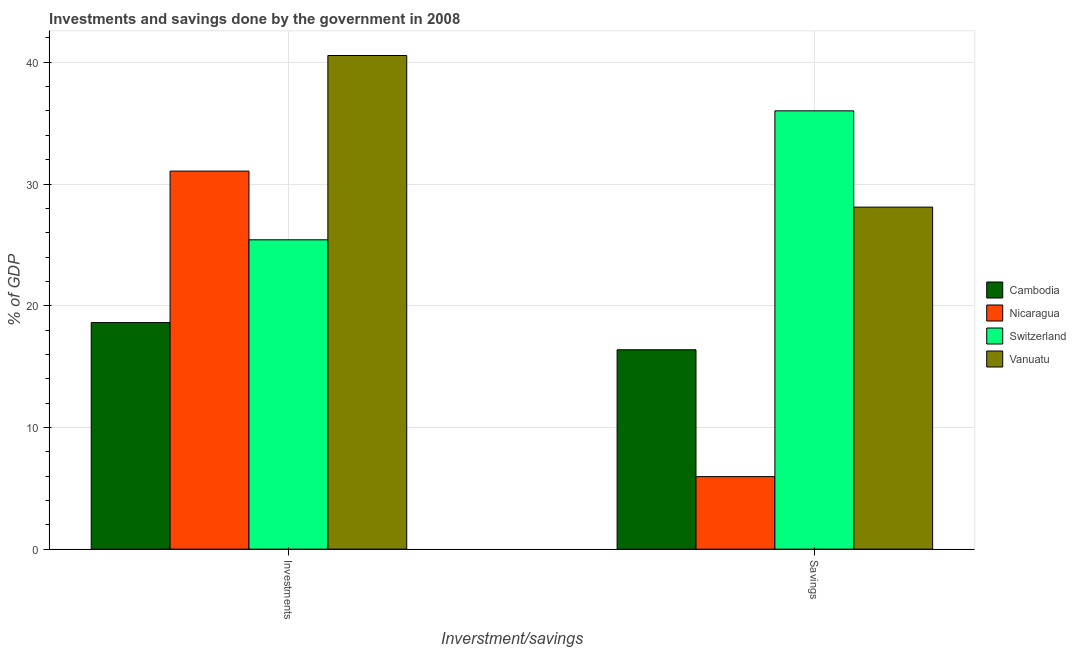How many groups of bars are there?
Make the answer very short. 2. Are the number of bars per tick equal to the number of legend labels?
Your response must be concise. Yes. Are the number of bars on each tick of the X-axis equal?
Give a very brief answer. Yes. How many bars are there on the 2nd tick from the right?
Provide a succinct answer. 4. What is the label of the 2nd group of bars from the left?
Provide a short and direct response. Savings. What is the savings of government in Switzerland?
Provide a short and direct response. 36.01. Across all countries, what is the maximum investments of government?
Your answer should be very brief. 40.56. Across all countries, what is the minimum savings of government?
Make the answer very short. 5.96. In which country was the investments of government maximum?
Your response must be concise. Vanuatu. In which country was the savings of government minimum?
Give a very brief answer. Nicaragua. What is the total investments of government in the graph?
Provide a short and direct response. 115.65. What is the difference between the savings of government in Cambodia and that in Switzerland?
Ensure brevity in your answer.  -19.63. What is the difference between the investments of government in Cambodia and the savings of government in Vanuatu?
Provide a succinct answer. -9.49. What is the average savings of government per country?
Offer a very short reply. 21.61. What is the difference between the investments of government and savings of government in Vanuatu?
Your response must be concise. 12.46. In how many countries, is the investments of government greater than 10 %?
Offer a terse response. 4. What is the ratio of the investments of government in Cambodia to that in Vanuatu?
Ensure brevity in your answer.  0.46. In how many countries, is the investments of government greater than the average investments of government taken over all countries?
Your answer should be compact. 2. What does the 1st bar from the left in Investments represents?
Keep it short and to the point. Cambodia. What does the 3rd bar from the right in Investments represents?
Make the answer very short. Nicaragua. Are all the bars in the graph horizontal?
Provide a succinct answer. No. How many countries are there in the graph?
Make the answer very short. 4. What is the difference between two consecutive major ticks on the Y-axis?
Ensure brevity in your answer.  10. How many legend labels are there?
Ensure brevity in your answer.  4. How are the legend labels stacked?
Your answer should be compact. Vertical. What is the title of the graph?
Your answer should be compact. Investments and savings done by the government in 2008. What is the label or title of the X-axis?
Give a very brief answer. Inverstment/savings. What is the label or title of the Y-axis?
Offer a very short reply. % of GDP. What is the % of GDP of Cambodia in Investments?
Offer a very short reply. 18.62. What is the % of GDP in Nicaragua in Investments?
Keep it short and to the point. 31.06. What is the % of GDP in Switzerland in Investments?
Offer a terse response. 25.42. What is the % of GDP of Vanuatu in Investments?
Your answer should be very brief. 40.56. What is the % of GDP of Cambodia in Savings?
Offer a very short reply. 16.38. What is the % of GDP of Nicaragua in Savings?
Give a very brief answer. 5.96. What is the % of GDP in Switzerland in Savings?
Ensure brevity in your answer.  36.01. What is the % of GDP in Vanuatu in Savings?
Ensure brevity in your answer.  28.1. Across all Inverstment/savings, what is the maximum % of GDP in Cambodia?
Offer a very short reply. 18.62. Across all Inverstment/savings, what is the maximum % of GDP of Nicaragua?
Give a very brief answer. 31.06. Across all Inverstment/savings, what is the maximum % of GDP of Switzerland?
Keep it short and to the point. 36.01. Across all Inverstment/savings, what is the maximum % of GDP in Vanuatu?
Your answer should be very brief. 40.56. Across all Inverstment/savings, what is the minimum % of GDP of Cambodia?
Give a very brief answer. 16.38. Across all Inverstment/savings, what is the minimum % of GDP of Nicaragua?
Keep it short and to the point. 5.96. Across all Inverstment/savings, what is the minimum % of GDP of Switzerland?
Your response must be concise. 25.42. Across all Inverstment/savings, what is the minimum % of GDP of Vanuatu?
Make the answer very short. 28.1. What is the total % of GDP of Cambodia in the graph?
Your answer should be compact. 35. What is the total % of GDP of Nicaragua in the graph?
Make the answer very short. 37.02. What is the total % of GDP in Switzerland in the graph?
Offer a terse response. 61.43. What is the total % of GDP of Vanuatu in the graph?
Offer a terse response. 68.66. What is the difference between the % of GDP of Cambodia in Investments and that in Savings?
Ensure brevity in your answer.  2.23. What is the difference between the % of GDP in Nicaragua in Investments and that in Savings?
Offer a terse response. 25.1. What is the difference between the % of GDP of Switzerland in Investments and that in Savings?
Offer a terse response. -10.6. What is the difference between the % of GDP of Vanuatu in Investments and that in Savings?
Your response must be concise. 12.46. What is the difference between the % of GDP in Cambodia in Investments and the % of GDP in Nicaragua in Savings?
Give a very brief answer. 12.66. What is the difference between the % of GDP of Cambodia in Investments and the % of GDP of Switzerland in Savings?
Your response must be concise. -17.4. What is the difference between the % of GDP of Cambodia in Investments and the % of GDP of Vanuatu in Savings?
Your response must be concise. -9.49. What is the difference between the % of GDP in Nicaragua in Investments and the % of GDP in Switzerland in Savings?
Provide a short and direct response. -4.95. What is the difference between the % of GDP in Nicaragua in Investments and the % of GDP in Vanuatu in Savings?
Give a very brief answer. 2.96. What is the difference between the % of GDP in Switzerland in Investments and the % of GDP in Vanuatu in Savings?
Offer a very short reply. -2.69. What is the average % of GDP of Cambodia per Inverstment/savings?
Make the answer very short. 17.5. What is the average % of GDP in Nicaragua per Inverstment/savings?
Offer a terse response. 18.51. What is the average % of GDP in Switzerland per Inverstment/savings?
Give a very brief answer. 30.71. What is the average % of GDP in Vanuatu per Inverstment/savings?
Your answer should be compact. 34.33. What is the difference between the % of GDP in Cambodia and % of GDP in Nicaragua in Investments?
Your response must be concise. -12.44. What is the difference between the % of GDP in Cambodia and % of GDP in Switzerland in Investments?
Your answer should be compact. -6.8. What is the difference between the % of GDP in Cambodia and % of GDP in Vanuatu in Investments?
Give a very brief answer. -21.94. What is the difference between the % of GDP of Nicaragua and % of GDP of Switzerland in Investments?
Make the answer very short. 5.64. What is the difference between the % of GDP in Nicaragua and % of GDP in Vanuatu in Investments?
Your answer should be compact. -9.5. What is the difference between the % of GDP of Switzerland and % of GDP of Vanuatu in Investments?
Ensure brevity in your answer.  -15.14. What is the difference between the % of GDP of Cambodia and % of GDP of Nicaragua in Savings?
Provide a short and direct response. 10.42. What is the difference between the % of GDP in Cambodia and % of GDP in Switzerland in Savings?
Provide a succinct answer. -19.63. What is the difference between the % of GDP in Cambodia and % of GDP in Vanuatu in Savings?
Provide a short and direct response. -11.72. What is the difference between the % of GDP in Nicaragua and % of GDP in Switzerland in Savings?
Provide a succinct answer. -30.05. What is the difference between the % of GDP in Nicaragua and % of GDP in Vanuatu in Savings?
Offer a terse response. -22.14. What is the difference between the % of GDP of Switzerland and % of GDP of Vanuatu in Savings?
Keep it short and to the point. 7.91. What is the ratio of the % of GDP of Cambodia in Investments to that in Savings?
Give a very brief answer. 1.14. What is the ratio of the % of GDP in Nicaragua in Investments to that in Savings?
Give a very brief answer. 5.21. What is the ratio of the % of GDP in Switzerland in Investments to that in Savings?
Offer a very short reply. 0.71. What is the ratio of the % of GDP of Vanuatu in Investments to that in Savings?
Your answer should be very brief. 1.44. What is the difference between the highest and the second highest % of GDP in Cambodia?
Offer a very short reply. 2.23. What is the difference between the highest and the second highest % of GDP in Nicaragua?
Give a very brief answer. 25.1. What is the difference between the highest and the second highest % of GDP of Switzerland?
Make the answer very short. 10.6. What is the difference between the highest and the second highest % of GDP of Vanuatu?
Ensure brevity in your answer.  12.46. What is the difference between the highest and the lowest % of GDP in Cambodia?
Provide a short and direct response. 2.23. What is the difference between the highest and the lowest % of GDP in Nicaragua?
Ensure brevity in your answer.  25.1. What is the difference between the highest and the lowest % of GDP in Switzerland?
Ensure brevity in your answer.  10.6. What is the difference between the highest and the lowest % of GDP in Vanuatu?
Keep it short and to the point. 12.46. 